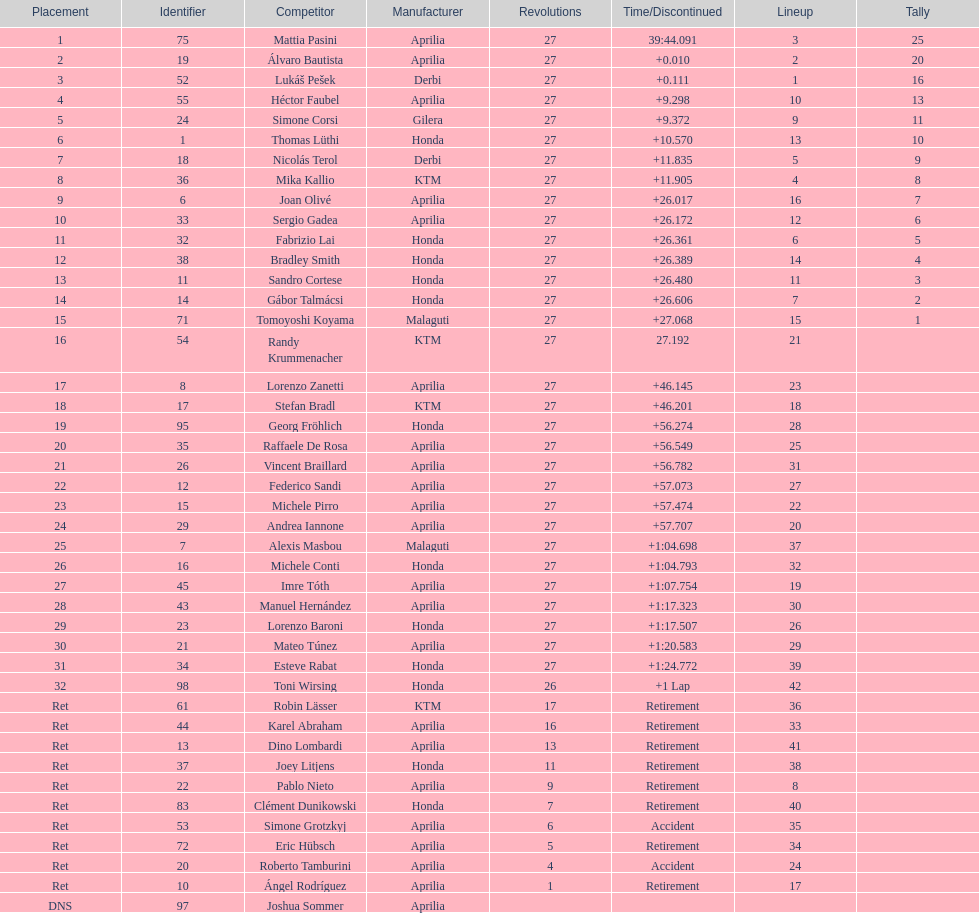How many racers did not use an aprilia or a honda? 9. 